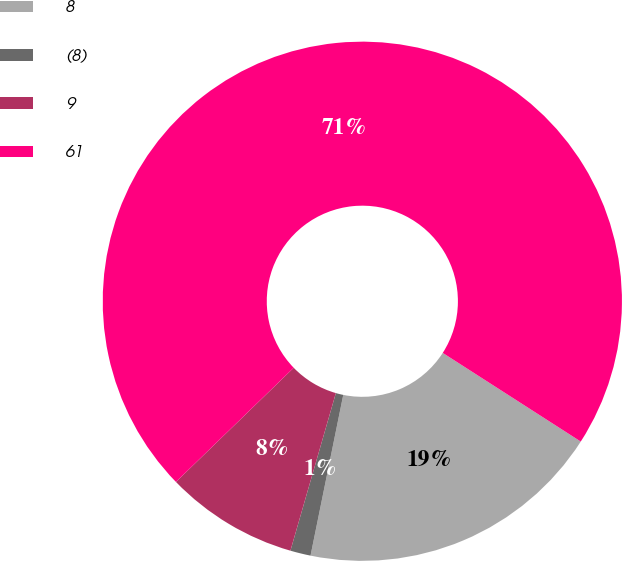Convert chart. <chart><loc_0><loc_0><loc_500><loc_500><pie_chart><fcel>8<fcel>(8)<fcel>9<fcel>61<nl><fcel>19.11%<fcel>1.27%<fcel>8.28%<fcel>71.34%<nl></chart> 